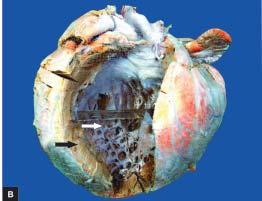s one marrow trephine biopsy in aplastic anaemia heavier?
Answer the question using a single word or phrase. No 